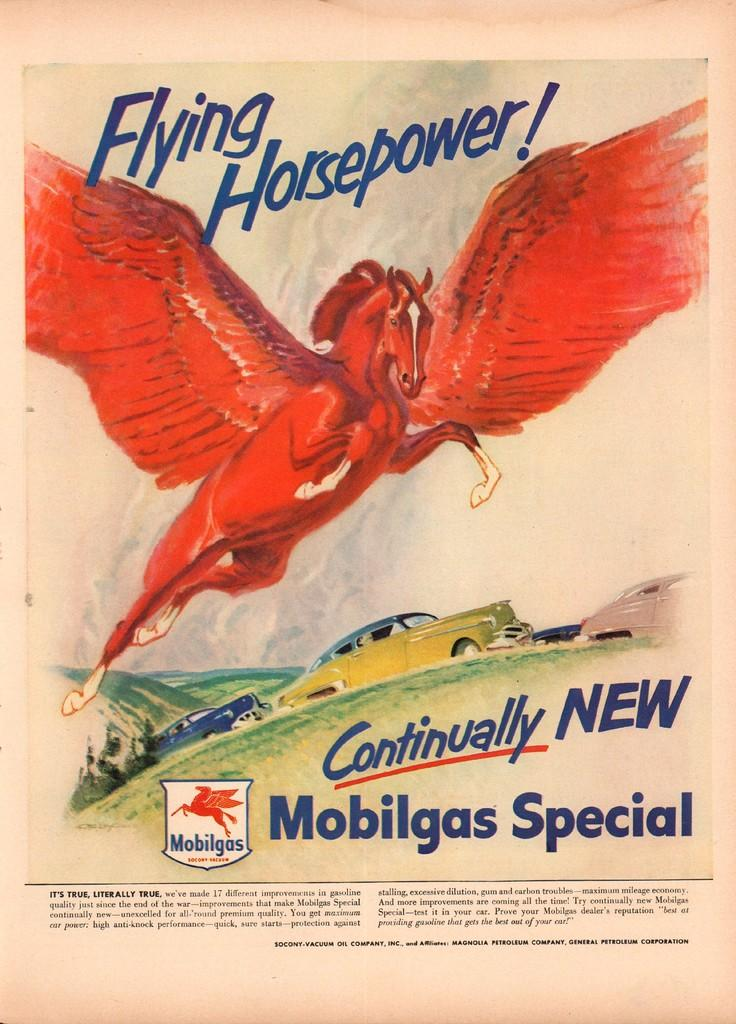What is depicted on the paper in the image? The paper contains a drawing of a flying horse, as well as drawings of cars and hills. Is there any text on the paper? Yes, there is writing on the paper. What other design element can be seen on the paper? There is a logo on the paper. What type of noise does the paper make when it is turned to the next page? There is no indication of turning pages or making noise in the image, as it only shows a paper with drawings and writing. 